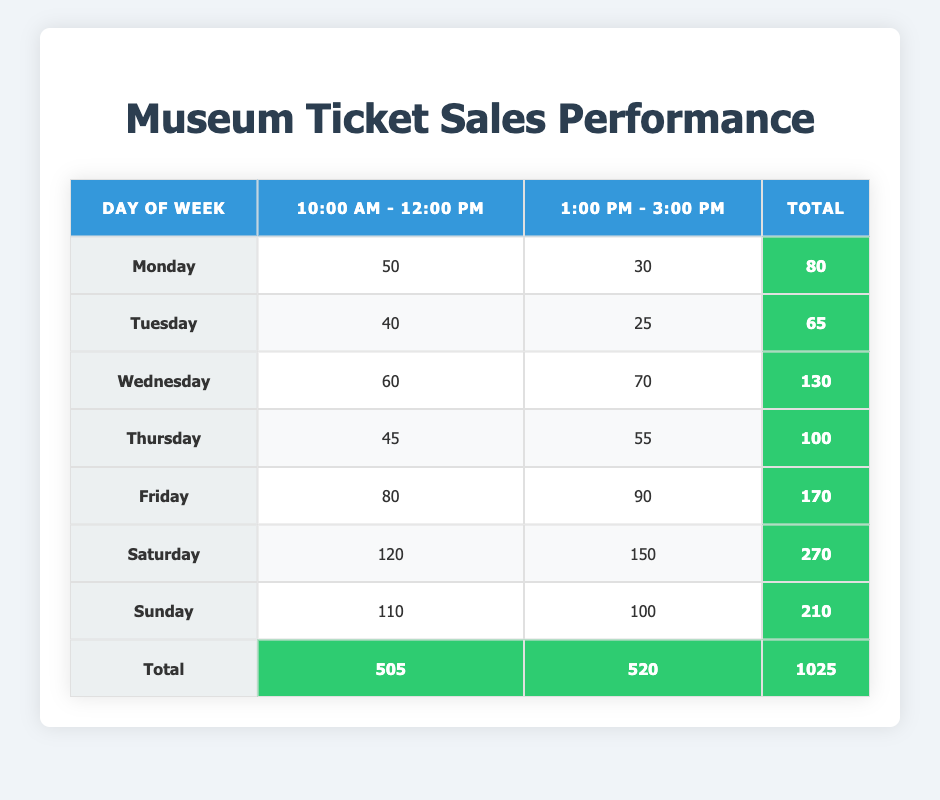What day has the highest total ticket sales? Looking through the total column for each day, Saturday has the highest total ticket sales with 270 tickets sold.
Answer: Saturday How many tickets were sold on Thursday during the 1:00 PM - 3:00 PM time slot? Referring to the Thursday row, the number of tickets sold during the 1:00 PM - 3:00 PM time slot is 55.
Answer: 55 What is the total number of tickets sold for both time slots on Sunday? By adding the two time slots on Sunday: 110 (10:00 AM - 12:00 PM) + 100 (1:00 PM - 3:00 PM) = 210.
Answer: 210 Is the number of tickets sold during the 10:00 AM - 12:00 PM slot higher than during the 1:00 PM - 3:00 PM slot for any day? I will compare the tickets sold in both time slots for every day. On Friday and Saturday, the tickets sold during the 1:00 PM - 3:00 PM slot (90 and 150, respectively) are higher than the 10:00 AM - 12:00 PM slot (80 and 120, respectively). Therefore, the answer is yes.
Answer: Yes What is the average number of tickets sold during the 10:00 AM - 12:00 PM time slot over all days? To calculate the average, I sum the tickets sold during the 10:00 AM - 12:00 PM time slot (50 + 40 + 60 + 45 + 80 + 120 + 110 = 505) and divide it by 7 (the number of days) to get 505 / 7 = approximately 72.14.
Answer: 72.14 Which day sold the least tickets during the 10:00 AM - 12:00 PM time slot? Looking at the 10:00 AM - 12:00 PM column, Monday has the least number of tickets sold at 50.
Answer: Monday How much more revenue was generated from ticket sales during the 1:00 PM - 3:00 PM time slot compared to the 10:00 AM - 12:00 PM slot for all days combined? First, I sum the total tickets sold for both time slots: For the 1:00 PM - 3:00 PM slot, it's 30 + 25 + 70 + 55 + 90 + 150 + 100 = 520. For the 10:00 AM - 12:00 PM slot, it's 505. The difference is 520 - 505 = 15, indicating that more revenue was generated during the afternoon slot.
Answer: 15 On which day did the highest number of tickets get sold during the 10:00 AM - 12:00 PM time slot? By examining the 10:00 AM - 12:00 PM column, Saturday has the highest number of tickets sold with 120.
Answer: Saturday Are the total ticket sales for all days above or below 1000? The total ticket sales according to the last row is 1025, which is above 1000. Thus, the answer is yes.
Answer: Yes 